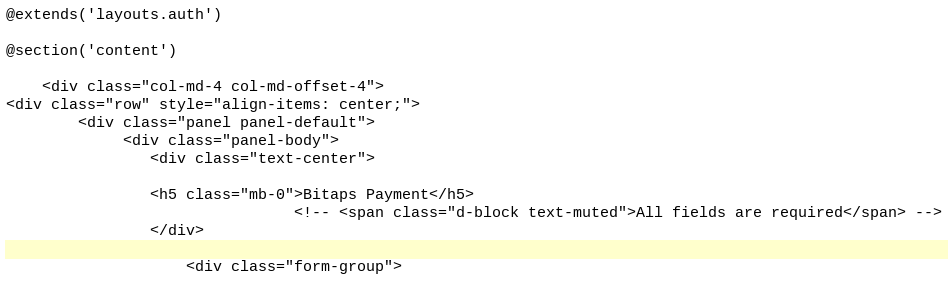Convert code to text. <code><loc_0><loc_0><loc_500><loc_500><_PHP_>@extends('layouts.auth')

@section('content')

    <div class="col-md-4 col-md-offset-4">
<div class="row" style="align-items: center;">
        <div class="panel panel-default">
             <div class="panel-body">
                <div class="text-center">
               
                <h5 class="mb-0">Bitaps Payment</h5>
                                <!-- <span class="d-block text-muted">All fields are required</span> -->
                </div>
       
                    <div class="form-group"></code> 